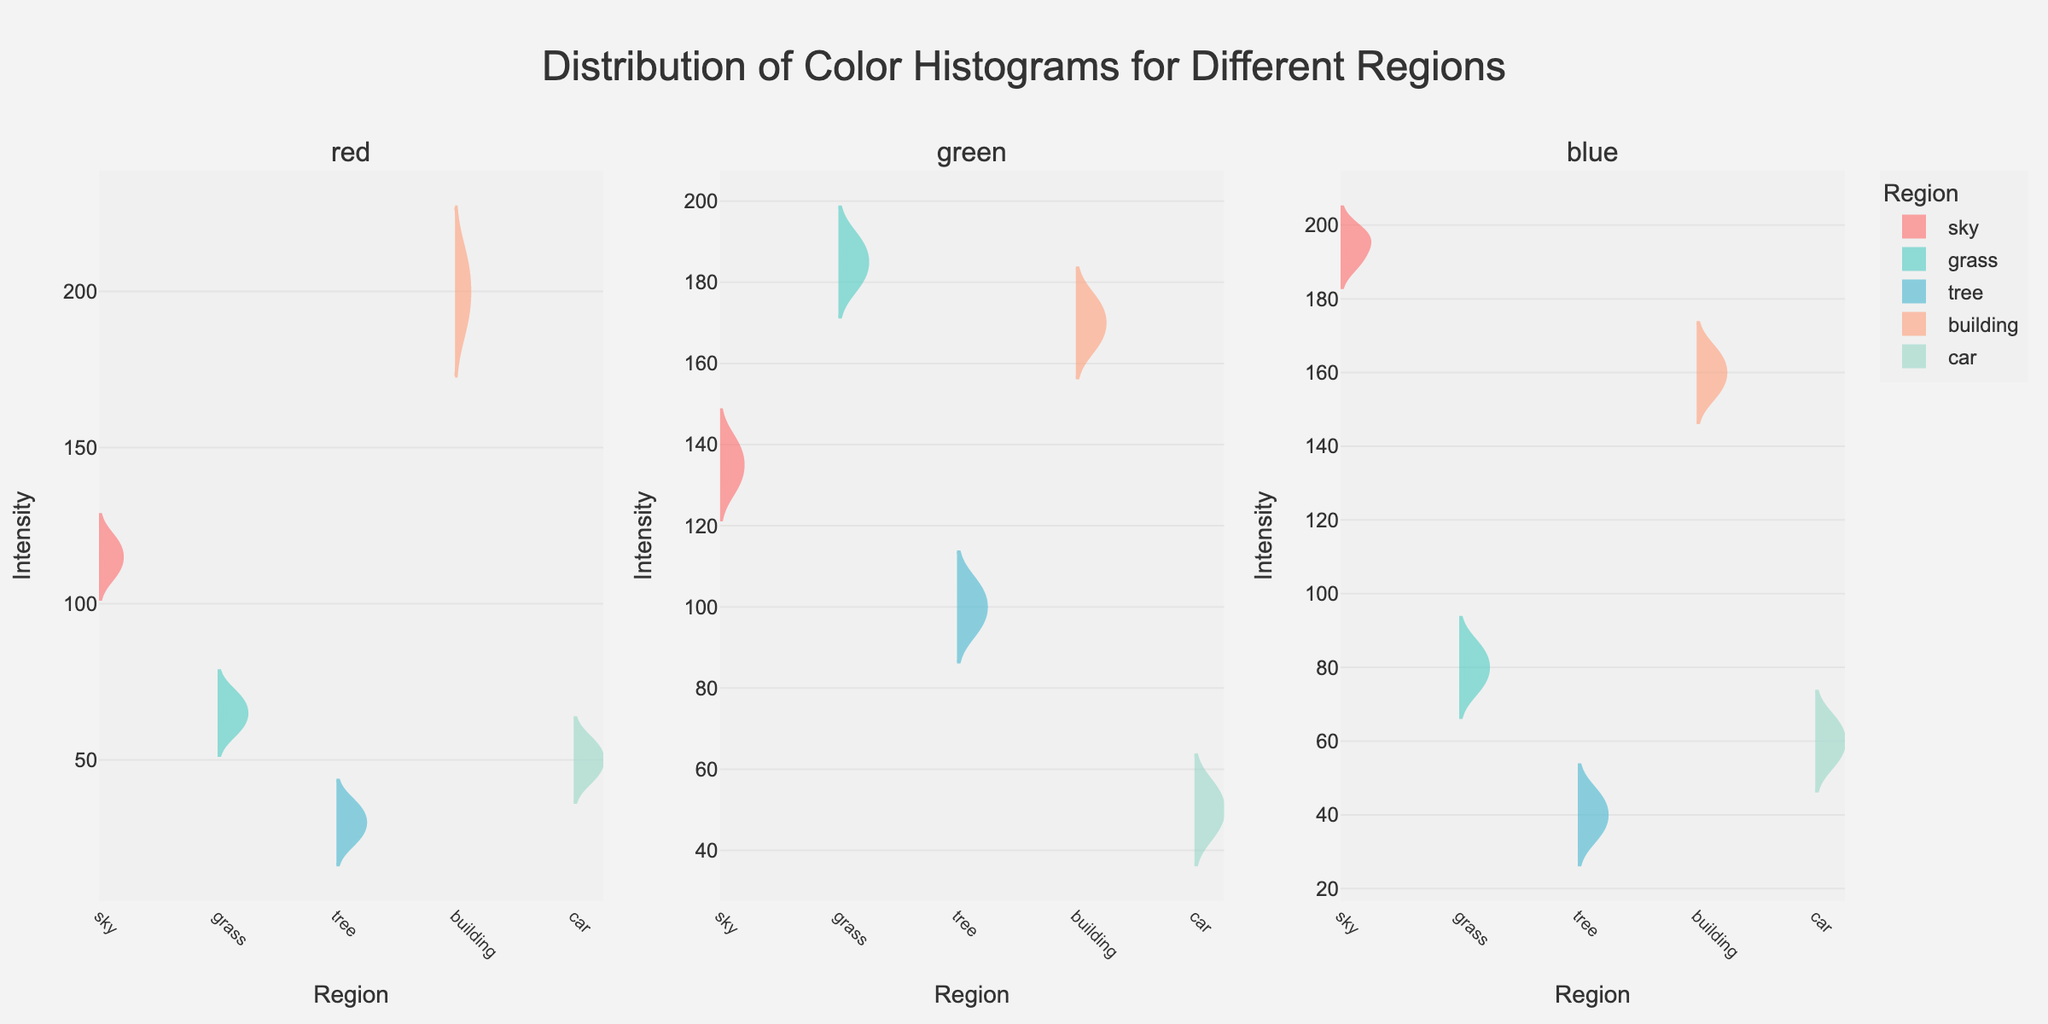What is the title of the figure? The title is prominently displayed at the top of the figure. It reads: "Distribution of Color Histograms for Different Regions".
Answer: Distribution of Color Histograms for Different Regions Which color has the highest intensity in the 'sky' region? To determine the highest intensity, look at the red, green, and blue violin plots for the 'sky' region. The highest value is found by comparing the maxima.
Answer: blue Which region has the lowest median green intensity? Compare the median values of the green intensity for all regions. The region with the lowest median will have the lowest central point in the violin plot for green.
Answer: car How many different objects or regions are visualized in the figure? Count the unique entries in the x-axis for each subplot of the violin plots. There are five regions (sky, grass, tree, building, car).
Answer: 5 Which region's color intensity shows the widest range in the blue channel? Look at the spread of the violin plots in the blue channel for each region. The region with the widest violin plot has the broadest range.
Answer: sky What is the mean red intensity for the 'building' region? Observe the red violin plot for the 'building' region. The mean value is indicated by the meanline visible in the plot.
Answer: approximately 200 Does any region have overlapping ranges for green and blue intensities? Compare the violin plots of green and blue for overlapping regions. Look for similar ranges or where the plots overlap significantly.
Answer: sky Which region has the most similar intensity distribution across all three colors? Observe the shape and spread of the violin plots for red, green, and blue for each region. The region with the most similar distributions will have similarly shaped plots across the colors.
Answer: tree 